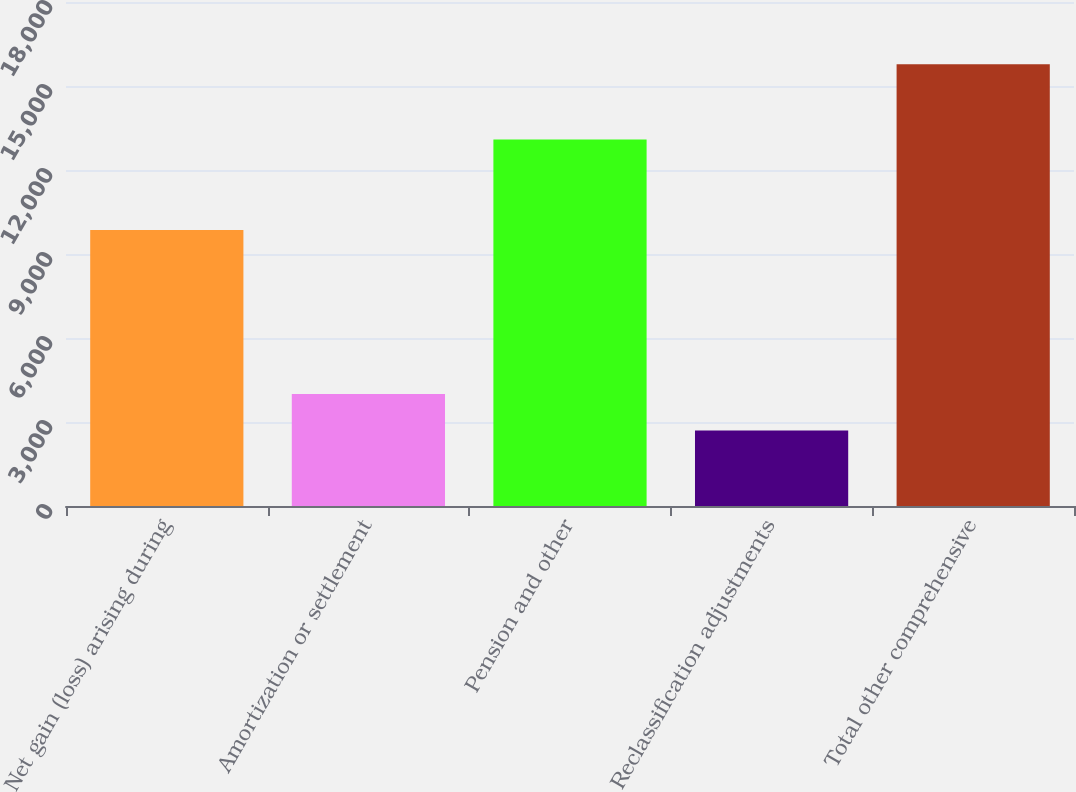Convert chart. <chart><loc_0><loc_0><loc_500><loc_500><bar_chart><fcel>Net gain (loss) arising during<fcel>Amortization or settlement<fcel>Pension and other<fcel>Reclassification adjustments<fcel>Total other comprehensive<nl><fcel>9859<fcel>4000.5<fcel>13085<fcel>2692<fcel>15777<nl></chart> 